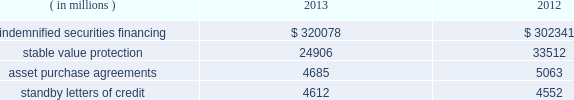State street corporation notes to consolidated financial statements ( continued ) with respect to the 5.25% ( 5.25 % ) subordinated bank notes due 2018 , state street bank is required to make semi- annual interest payments on the outstanding principal balance of the notes on april 15 and october 15 of each year , and the notes qualify for inclusion in tier 2 regulatory capital under current federal regulatory capital guidelines .
With respect to the 5.30% ( 5.30 % ) subordinated notes due 2016 and the floating-rate subordinated notes due 2015 , state street bank is required to make semi-annual interest payments on the outstanding principal balance of the 5.30% ( 5.30 % ) subordinated notes on january 15 and july 15 of each year , and quarterly interest payments on the outstanding principal balance of the floating-rate notes on march 8 , june 8 , september 8 and december 8 of each year .
Each of the subordinated notes qualifies for inclusion in tier 2 regulatory capital under current federal regulatory capital guidelines .
Note 11 .
Commitments , guarantees and contingencies commitments : we had unfunded off-balance sheet commitments to extend credit totaling $ 21.30 billion and $ 17.86 billion as of december 31 , 2013 and 2012 , respectively .
The potential losses associated with these commitments equal the gross contractual amounts , and do not consider the value of any collateral .
Approximately 75% ( 75 % ) of our unfunded commitments to extend credit expire within one year from the date of issue .
Since many of these commitments are expected to expire or renew without being drawn upon , the gross contractual amounts do not necessarily represent our future cash requirements .
Guarantees : off-balance sheet guarantees are composed of indemnified securities financing , stable value protection , unfunded commitments to purchase assets , and standby letters of credit .
The potential losses associated with these guarantees equal the gross contractual amounts , and do not consider the value of any collateral .
The table presents the aggregate gross contractual amounts of our off-balance sheet guarantees as of december 31 , 2013 and 2012 .
Amounts presented do not reflect participations to independent third parties. .
Indemnified securities financing on behalf of our clients , we lend their securities , as agent , to brokers and other institutions .
In most circumstances , we indemnify our clients for the fair market value of those securities against a failure of the borrower to return such securities .
We require the borrowers to maintain collateral in an amount equal to or in excess of 100% ( 100 % ) of the fair market value of the securities borrowed .
Securities on loan and the collateral are revalued daily to determine if additional collateral is necessary or if excess collateral is required to be returned to the borrower .
Collateral received in connection with our securities lending services is held by us as agent and is not recorded in our consolidated statement of condition .
The cash collateral held by us as agent is invested on behalf of our clients .
In certain cases , the cash collateral is invested in third-party repurchase agreements , for which we indemnify the client against loss of the principal invested .
We require the counterparty to the indemnified repurchase agreement to provide collateral in an amount equal to or in excess of 100% ( 100 % ) of the amount of the repurchase agreement .
In our role as agent , the indemnified repurchase agreements and the related collateral held by us are not recorded in our consolidated statement of condition. .
What percent did indemnified securities financing increase from 2012 to 2013? 
Computations: ((320078 - 302341) / 302341)
Answer: 0.05867. 